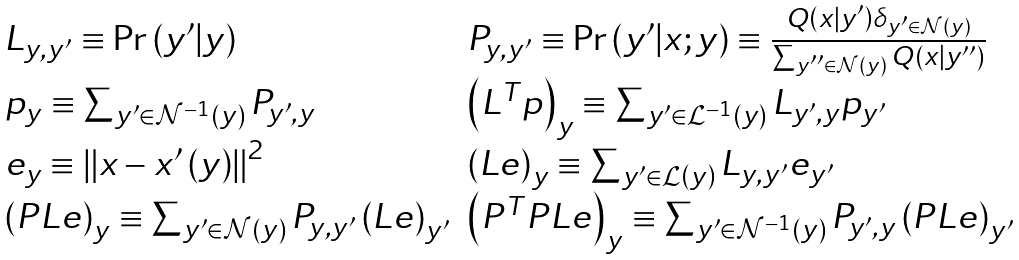Convert formula to latex. <formula><loc_0><loc_0><loc_500><loc_500>\begin{array} { l l } L _ { y , y ^ { \prime } } \equiv \Pr \left ( y ^ { \prime } | y \right ) & P _ { y , y ^ { \prime } } \equiv \Pr \left ( y ^ { \prime } | x ; y \right ) \equiv \frac { Q \left ( x | y ^ { \prime } \right ) \delta _ { y ^ { \prime } \in \mathcal { N } \left ( y \right ) } } { \sum _ { y ^ { \prime \prime } \in \mathcal { N } \left ( y \right ) } Q \left ( x | y ^ { \prime \prime } \right ) } \\ p _ { y } \equiv \sum _ { y ^ { \prime } \in \mathcal { N } ^ { - 1 } \left ( y \right ) } P _ { y ^ { \prime } , y } & \left ( L ^ { T } p \right ) _ { y } \equiv \sum _ { y ^ { \prime } \in \mathcal { L } ^ { - 1 } \left ( y \right ) } L _ { y ^ { \prime } , y } p _ { y ^ { \prime } } \\ e _ { y } \equiv \left \| x - x ^ { \prime } \left ( y \right ) \right \| ^ { 2 } & \left ( L e \right ) _ { y } \equiv \sum _ { y ^ { \prime } \in \mathcal { L } \left ( y \right ) } L _ { y , y ^ { \prime } } e _ { y ^ { \prime } } \\ \left ( P L e \right ) _ { y } \equiv \sum _ { y ^ { \prime } \in \mathcal { N } \left ( y \right ) } P _ { y , y ^ { \prime } } \left ( L e \right ) _ { y ^ { \prime } } & \left ( P ^ { T } P L e \right ) _ { y } \equiv \sum _ { y ^ { \prime } \in \mathcal { N } ^ { - 1 } \left ( y \right ) } P _ { y ^ { \prime } , y } \left ( P L e \right ) _ { y ^ { \prime } } \end{array}</formula> 